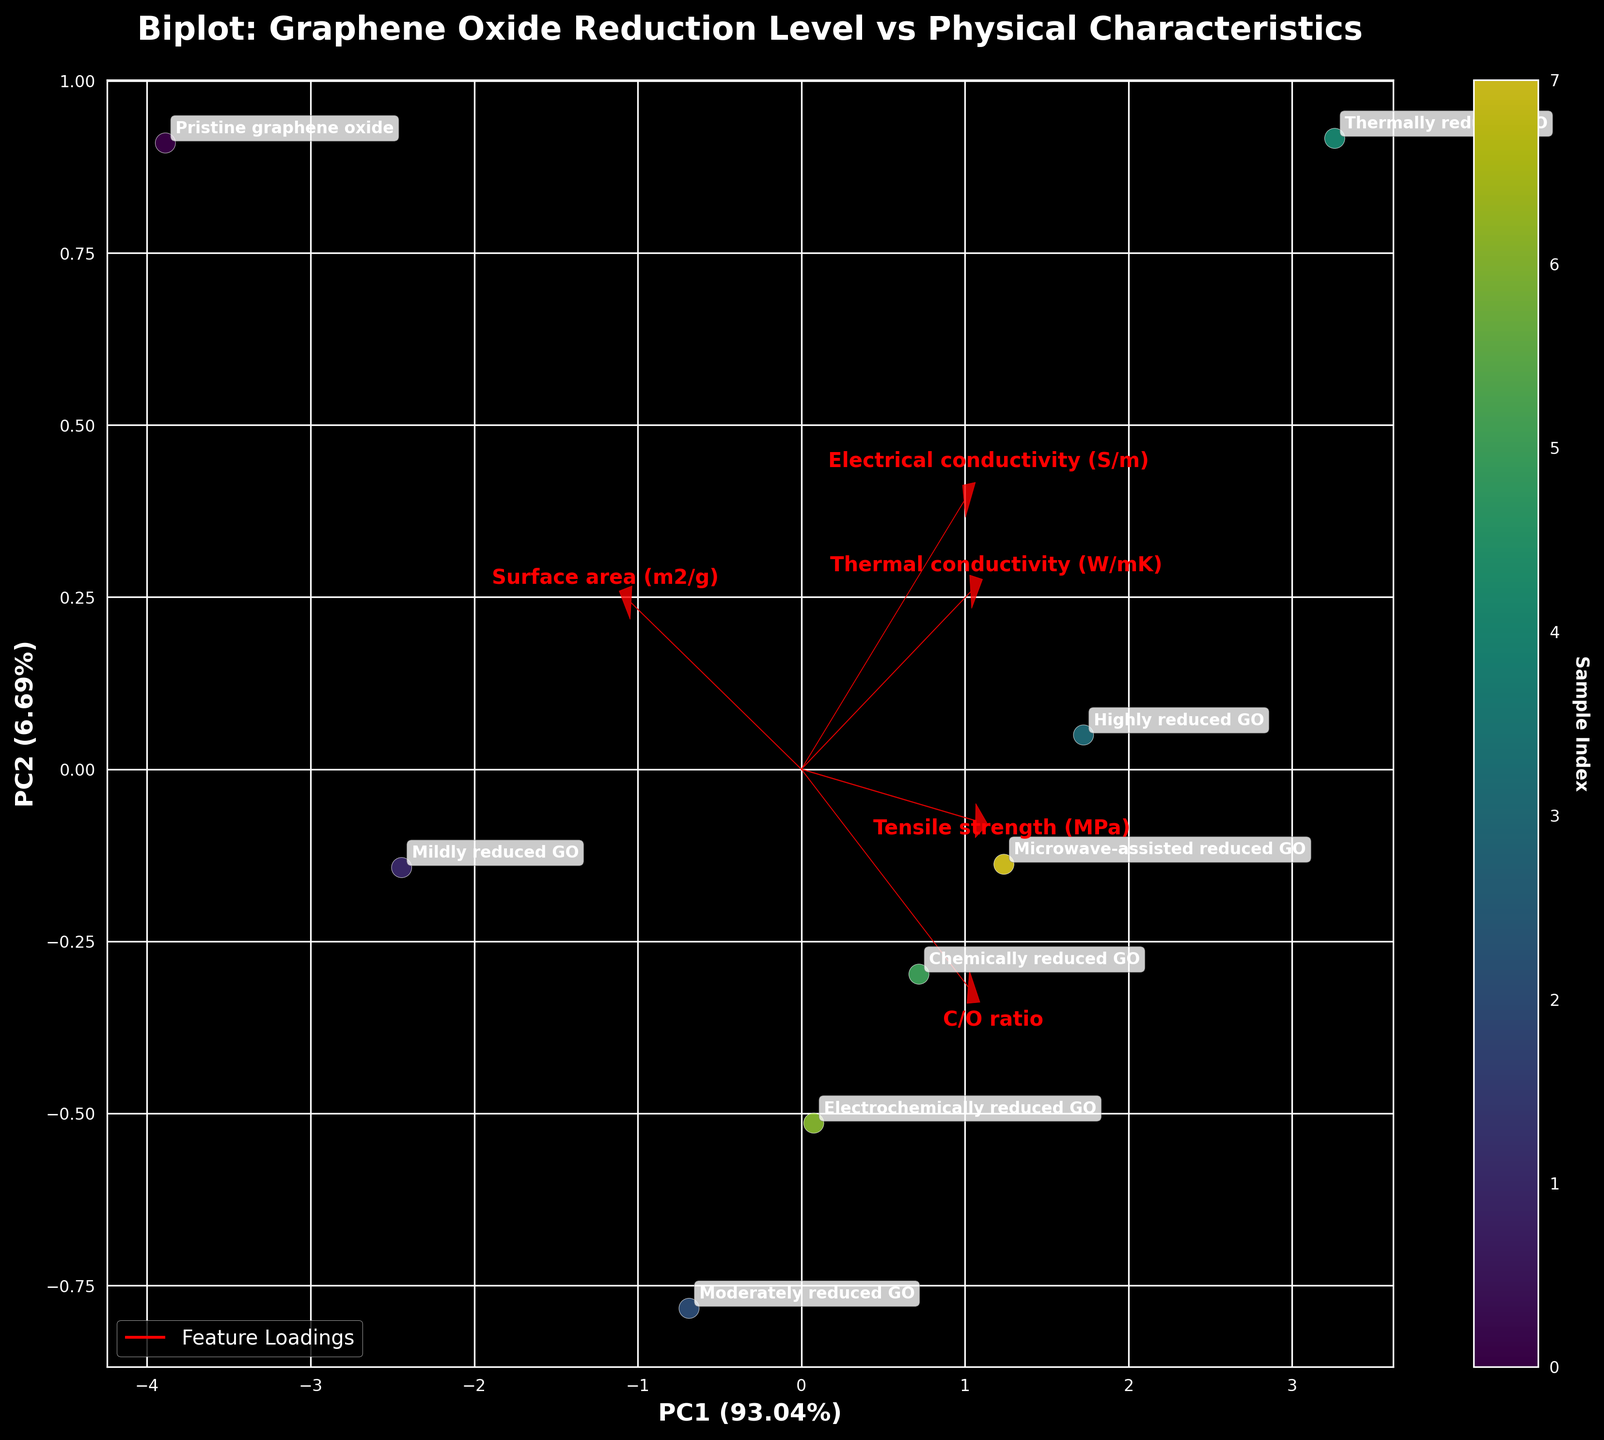What is the title of the plot? The title is usually placed at the top of the plot. In this case, it reads: "Biplot: Graphene Oxide Reduction Level vs Physical Characteristics."
Answer: Biplot: Graphene Oxide Reduction Level vs Physical Characteristics What are the labels of the x-axis and y-axis? The labels of the axes are indicated near the axes themselves. Here, the x-axis is labeled "PC1 (X%)" and the y-axis is labeled "PC2 (Y%)", where X and Y represent the explained variance ratios of the first two principal components.
Answer: PC1 (X%) and PC2 (Y%) How many samples are represented in the plot? Each data point on the plot represents a sample, and there are labels annotating each point. Counting them, we see there are 8 labeled samples: "Pristine graphene oxide," "Mildly reduced GO," "Moderately reduced GO," "Highly reduced GO," "Thermally reduced GO," "Chemically reduced GO," "Electrochemically reduced GO," and "Microwave-assisted reduced GO."
Answer: 8 Which sample is closest to the origin of the plot? By examining the position of each labeled data point in relation to the origin (0,0), we can see that "Pristine graphene oxide" is the closest sample to the origin.
Answer: Pristine graphene oxide Which characteristic has the largest loading in the first principal component (PC1)? The loadings are visualized as arrows, with their lengths indicating the magnitude of their contributions. The characteristic with the longest arrow in the direction of PC1 indicates the largest loading. Here, "Surface area (m2/g)" appears to have the largest loading in PC1.
Answer: Surface area (m2/g) How does the "Thermal conductivity (W/mK)" correlate with "Electrical conductivity (S/m)"? The direction of the loadings (arrows) shows the correlation. Arrows pointing in the same direction indicate a positive correlation, while arrows pointing in opposite directions signify a negative correlation. The "Thermal conductivity (W/mK)" and "Electrical conductivity (S/m)" arrows point in the same general direction, indicating a positive correlation.
Answer: Positively correlated Which two characteristics have the most similar loadings in the plot? The similarity of loadings can be seen by comparing the directions and lengths of the arrows. Here, "Tensile strength (MPa)" and "Thermal conductivity (W/mK)" have arrows pointing in similar directions and have similar lengths, indicating they have the most similar loadings.
Answer: Tensile strength (MPa) and Thermal conductivity (W/mK) Which sample shows the highest variance along the PC2 axis? The variance along PC2 is represented by the spread of data points in the vertical direction. The sample positioned furthest along the PC2 axis represents the highest variance in that component. In this plot, "Thermally reduced GO" has the highest dispersion along the PC2 axis.
Answer: Thermally reduced GO Which characteristic negatively loads on PC2 while positively loading on PC1? This can be determined by examining the direction of the loadings on the plot. A positive loading on PC1 and a negative loading on PC2 would mean the arrow points to the right and downward. Here, "Surface area (m2/g)" fits this description.
Answer: Surface area (m2/g) What percentage of variance is explained by PC1 and PC2 combined? The variance explained by PC1 and PC2 is typically provided in the axis labels. Assuming PC1 explains X% and PC2 explains Y%, these should sum to X + Y. For instance, if PC1 explains 60% and PC2 explains 30%, the combined variance is 90%.
Answer: X + Y% 